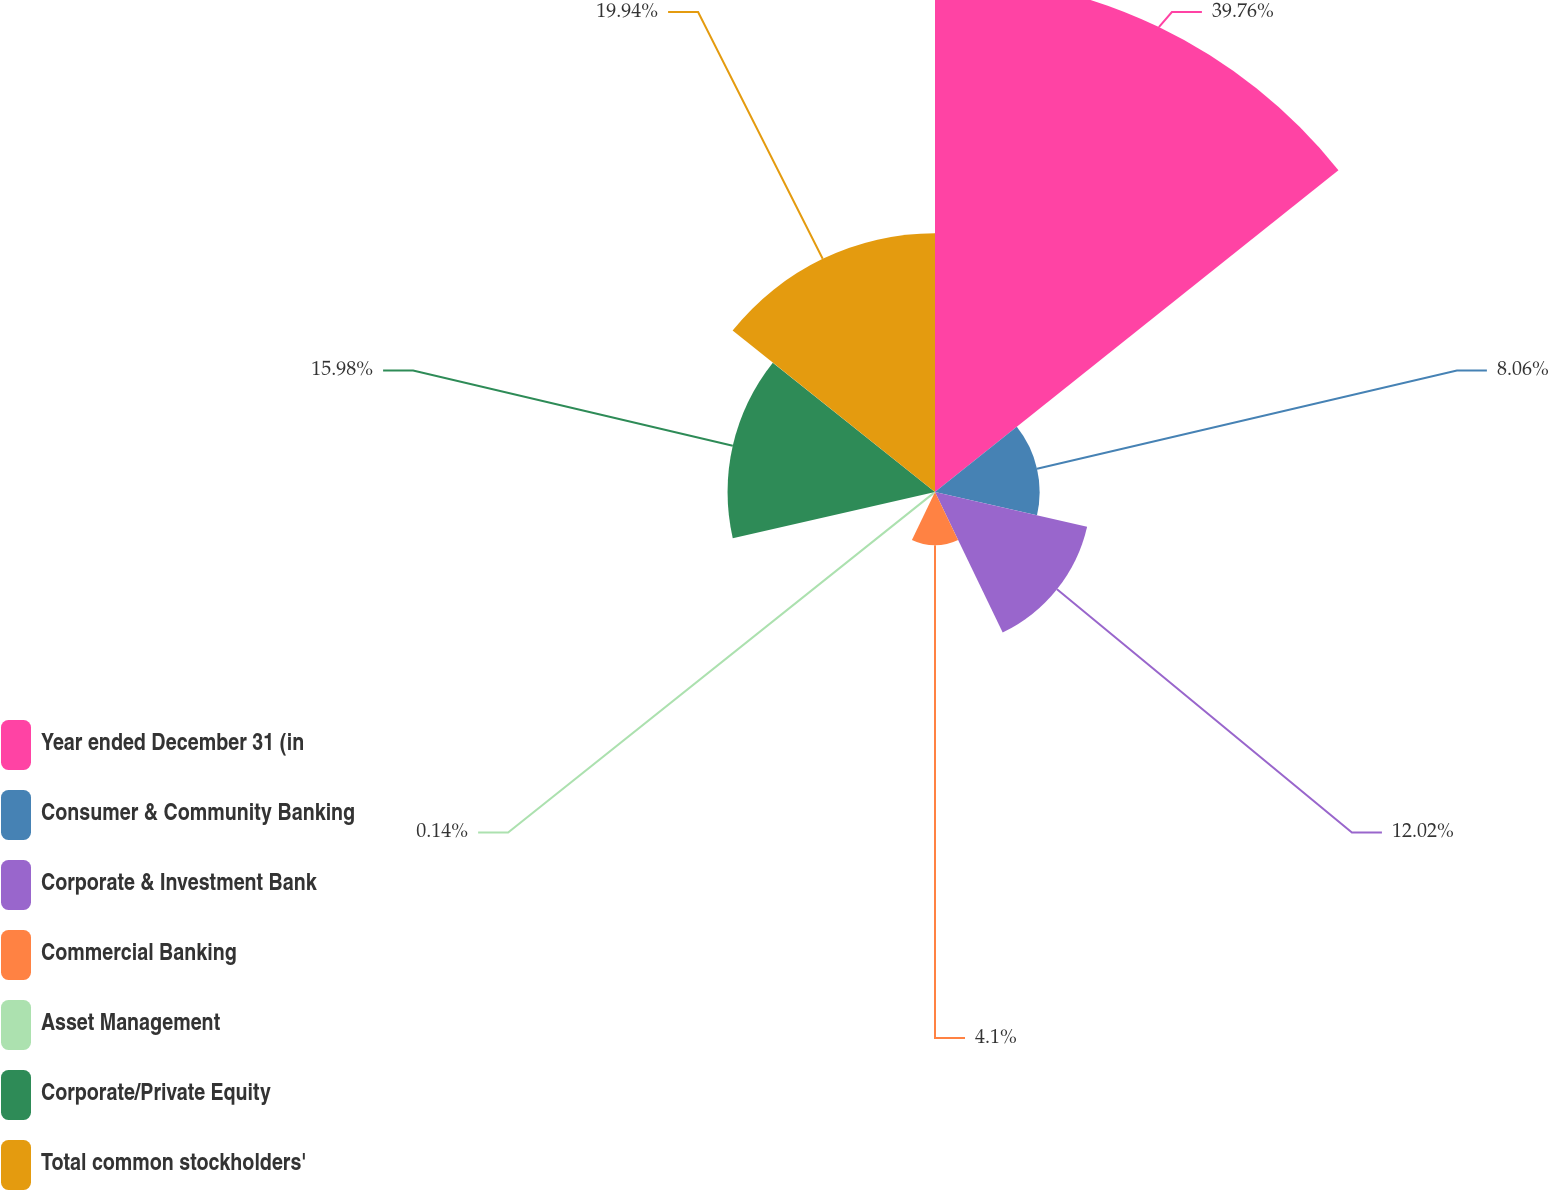Convert chart. <chart><loc_0><loc_0><loc_500><loc_500><pie_chart><fcel>Year ended December 31 (in<fcel>Consumer & Community Banking<fcel>Corporate & Investment Bank<fcel>Commercial Banking<fcel>Asset Management<fcel>Corporate/Private Equity<fcel>Total common stockholders'<nl><fcel>39.75%<fcel>8.06%<fcel>12.02%<fcel>4.1%<fcel>0.14%<fcel>15.98%<fcel>19.94%<nl></chart> 